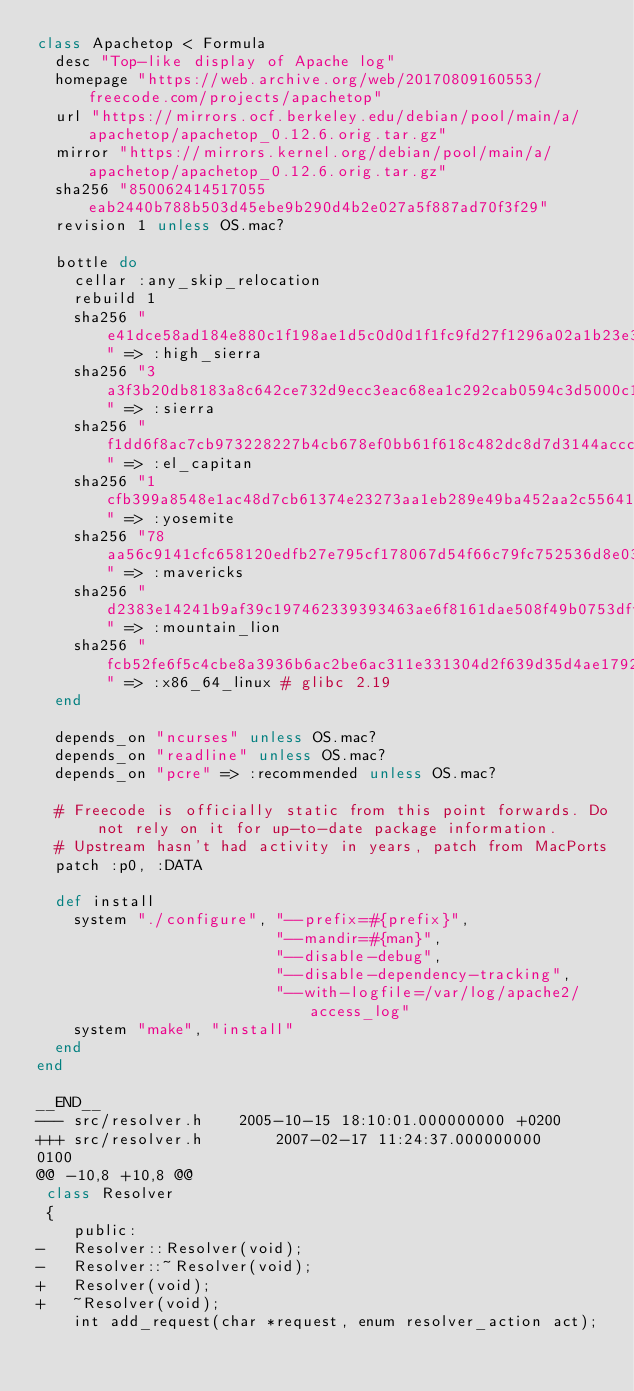Convert code to text. <code><loc_0><loc_0><loc_500><loc_500><_Ruby_>class Apachetop < Formula
  desc "Top-like display of Apache log"
  homepage "https://web.archive.org/web/20170809160553/freecode.com/projects/apachetop"
  url "https://mirrors.ocf.berkeley.edu/debian/pool/main/a/apachetop/apachetop_0.12.6.orig.tar.gz"
  mirror "https://mirrors.kernel.org/debian/pool/main/a/apachetop/apachetop_0.12.6.orig.tar.gz"
  sha256 "850062414517055eab2440b788b503d45ebe9b290d4b2e027a5f887ad70f3f29"
  revision 1 unless OS.mac?

  bottle do
    cellar :any_skip_relocation
    rebuild 1
    sha256 "e41dce58ad184e880c1f198ae1d5c0d0d1f1fc9fd27f1296a02a1b23e33c09cb" => :high_sierra
    sha256 "3a3f3b20db8183a8c642ce732d9ecc3eac68ea1c292cab0594c3d5000c181442" => :sierra
    sha256 "f1dd6f8ac7cb973228227b4cb678ef0bb61f618c482dc8d7d3144acccfebcf5b" => :el_capitan
    sha256 "1cfb399a8548e1ac48d7cb61374e23273aa1eb289e49ba452aa2c55641fe5bae" => :yosemite
    sha256 "78aa56c9141cfc658120edfb27e795cf178067d54f66c79fc752536d8e0335ea" => :mavericks
    sha256 "d2383e14241b9af39c197462339393463ae6f8161dae508f49b0753dff846287" => :mountain_lion
    sha256 "fcb52fe6f5c4cbe8a3936b6ac2be6ac311e331304d2f639d35d4ae1792491a35" => :x86_64_linux # glibc 2.19
  end

  depends_on "ncurses" unless OS.mac?
  depends_on "readline" unless OS.mac?
  depends_on "pcre" => :recommended unless OS.mac?

  # Freecode is officially static from this point forwards. Do not rely on it for up-to-date package information.
  # Upstream hasn't had activity in years, patch from MacPorts
  patch :p0, :DATA

  def install
    system "./configure", "--prefix=#{prefix}",
                          "--mandir=#{man}",
                          "--disable-debug",
                          "--disable-dependency-tracking",
                          "--with-logfile=/var/log/apache2/access_log"
    system "make", "install"
  end
end

__END__
--- src/resolver.h    2005-10-15 18:10:01.000000000 +0200
+++ src/resolver.h        2007-02-17 11:24:37.000000000 
0100
@@ -10,8 +10,8 @@
 class Resolver
 {
 	public:
-	Resolver::Resolver(void);
-	Resolver::~Resolver(void);
+	Resolver(void);
+	~Resolver(void);
 	int add_request(char *request, enum resolver_action act);
 
 
</code> 